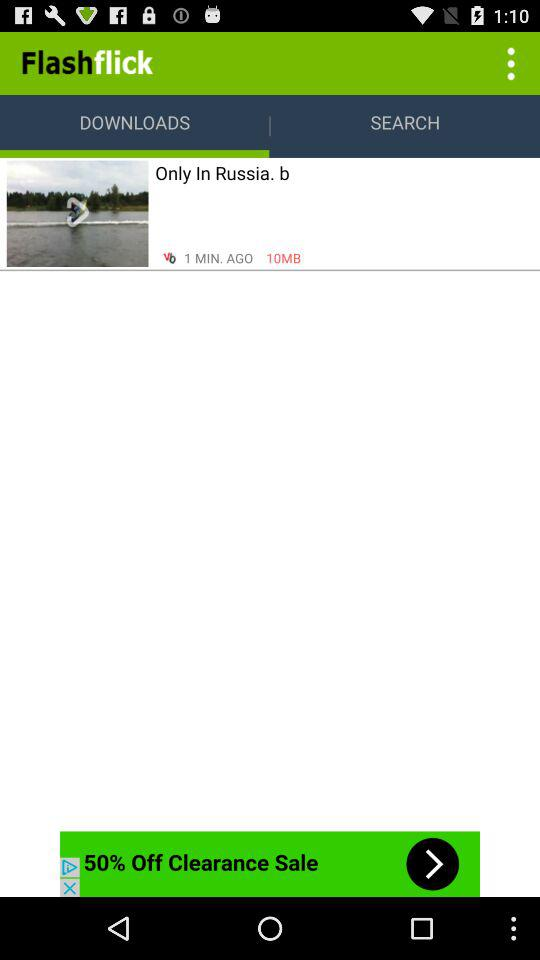How long ago was "Only In Russia. b" downloaded? "Only In Russia. b" was downloaded 1 minute ago. 